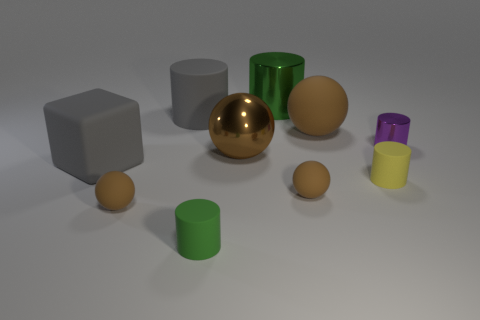The metal thing that is the same color as the large matte ball is what size?
Your answer should be compact. Large. Are there any spheres made of the same material as the yellow cylinder?
Ensure brevity in your answer.  Yes. Is the material of the purple object the same as the big gray cylinder?
Ensure brevity in your answer.  No. There is a large thing that is to the right of the green metallic cylinder; how many things are behind it?
Make the answer very short. 2. What number of gray things are matte cylinders or large rubber things?
Ensure brevity in your answer.  2. There is a green matte object in front of the large green metallic cylinder that is to the right of the gray rubber thing that is in front of the purple cylinder; what is its shape?
Your answer should be compact. Cylinder. What is the color of the matte ball that is the same size as the brown metallic ball?
Keep it short and to the point. Brown. What number of big rubber things are the same shape as the big green metal thing?
Your response must be concise. 1. There is a green rubber thing; is it the same size as the metal thing right of the tiny yellow rubber thing?
Your response must be concise. Yes. There is a green thing in front of the small object behind the small yellow cylinder; what shape is it?
Offer a very short reply. Cylinder. 